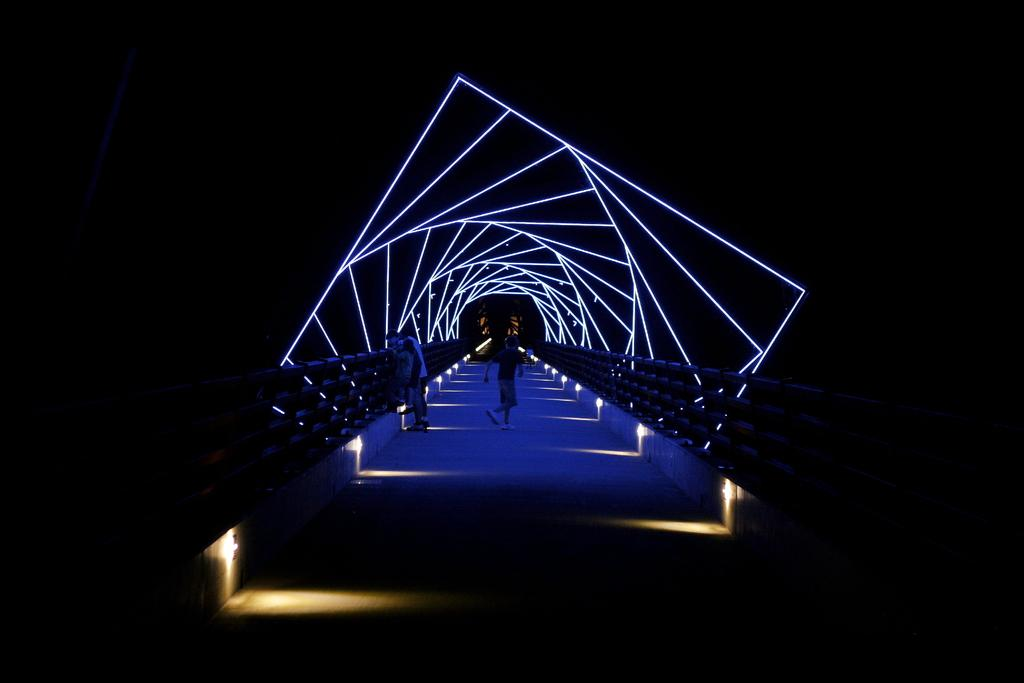What are the people in the image doing? The people in the image are standing and walking. Where are the people located in the image? The people are on a floor. What type of lighting can be seen in the image? There are different kinds of theme lights present in the image. What type of trousers is the actor wearing in the image? There is no actor present in the image, and therefore no trousers to describe. 